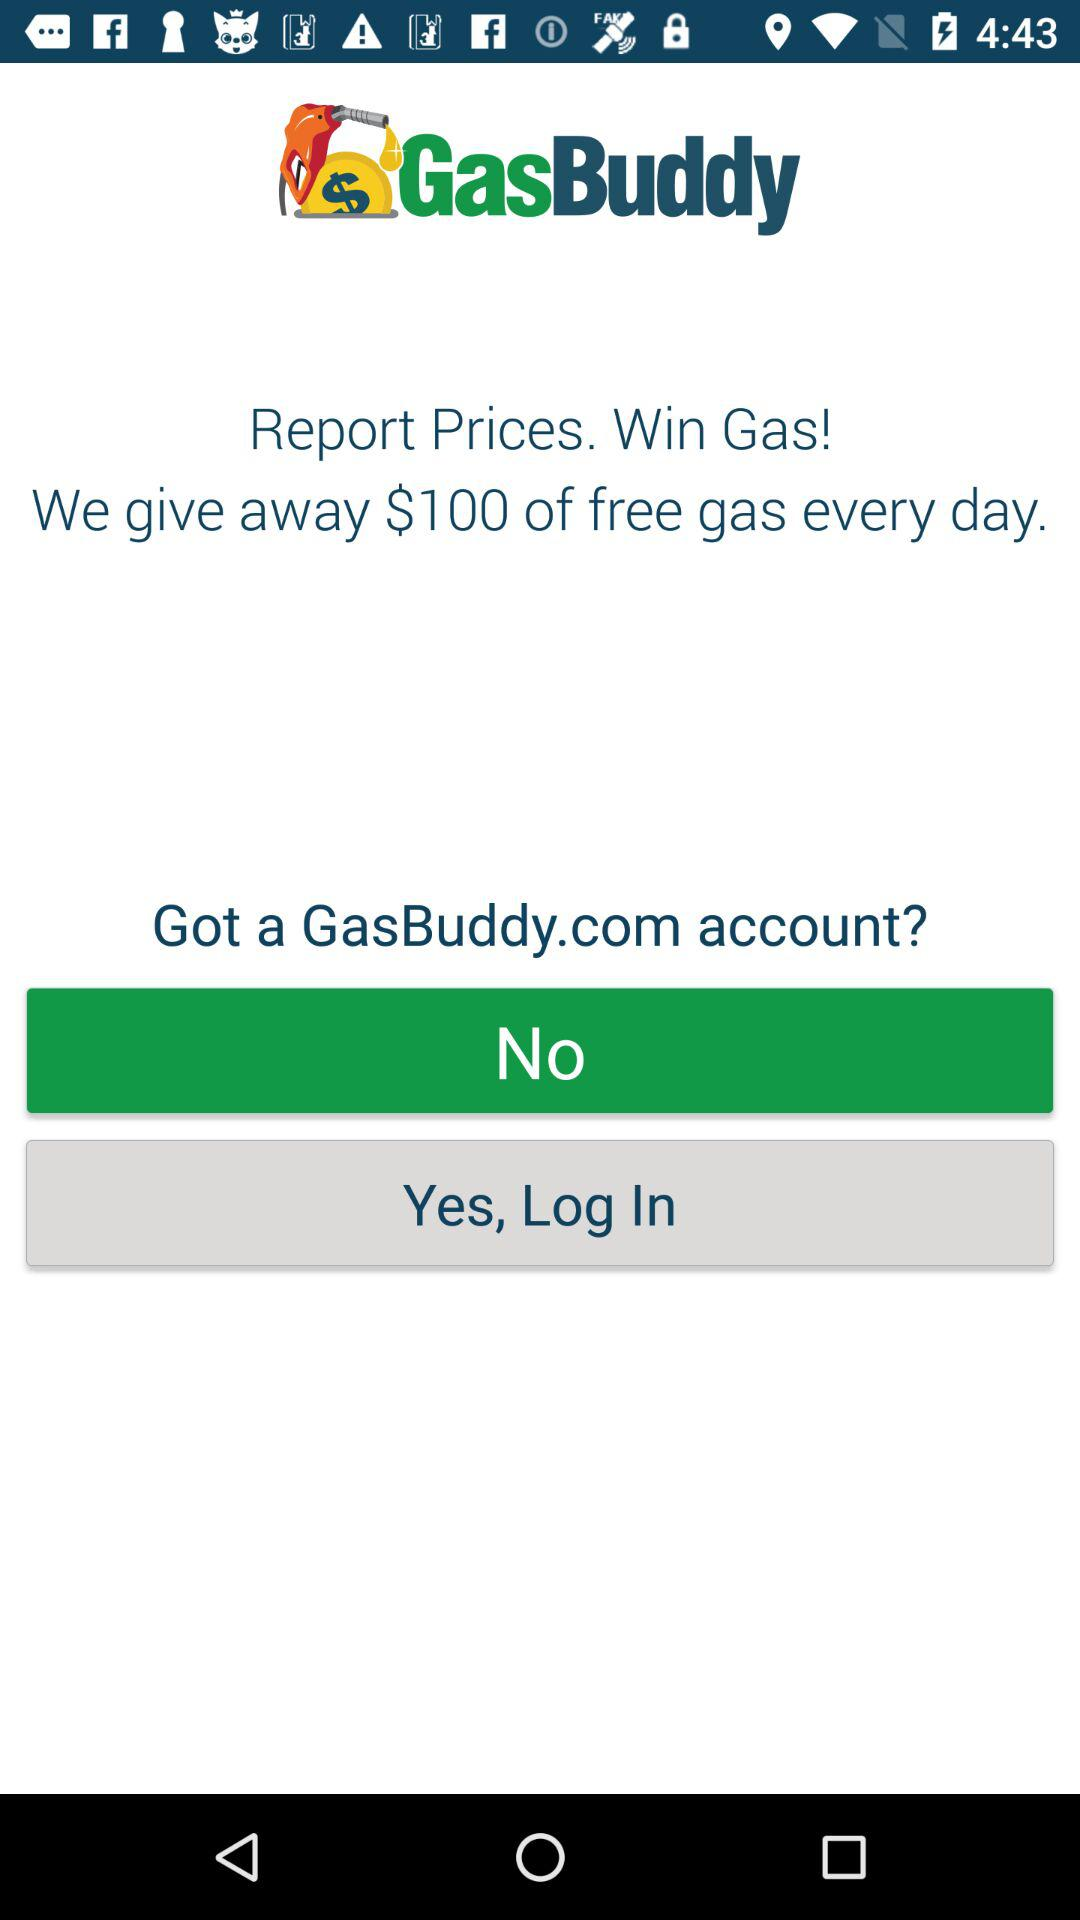How much gas is given away every day for free in terms of money? Every day, $100 of free gas is given away. 